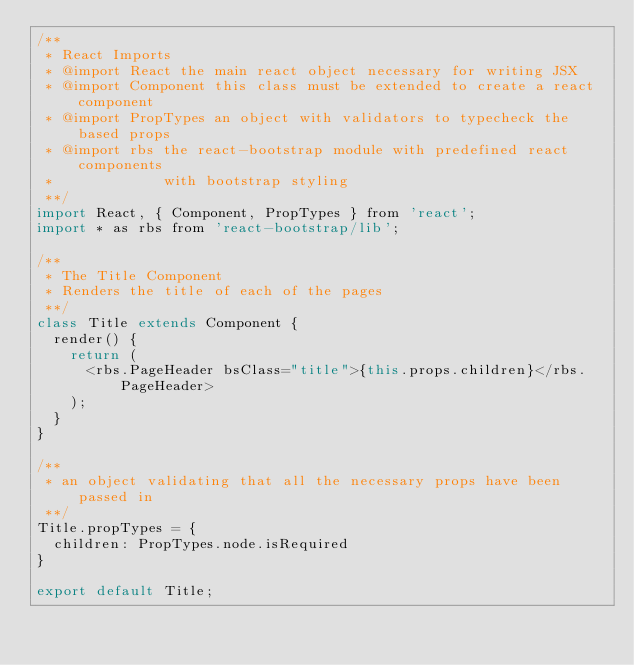<code> <loc_0><loc_0><loc_500><loc_500><_JavaScript_>/** 
 * React Imports
 * @import React the main react object necessary for writing JSX
 * @import Component this class must be extended to create a react component 
 * @import PropTypes an object with validators to typecheck the based props
 * @import rbs the react-bootstrap module with predefined react components 
 *             with bootstrap styling
 **/
import React, { Component, PropTypes } from 'react';
import * as rbs from 'react-bootstrap/lib';

/** 
 * The Title Component
 * Renders the title of each of the pages
 **/
class Title extends Component {
  render() {
    return (
      <rbs.PageHeader bsClass="title">{this.props.children}</rbs.PageHeader>
    );
  }
}

/**
 * an object validating that all the necessary props have been passed in 
 **/
Title.propTypes = {
  children: PropTypes.node.isRequired
}

export default Title;</code> 